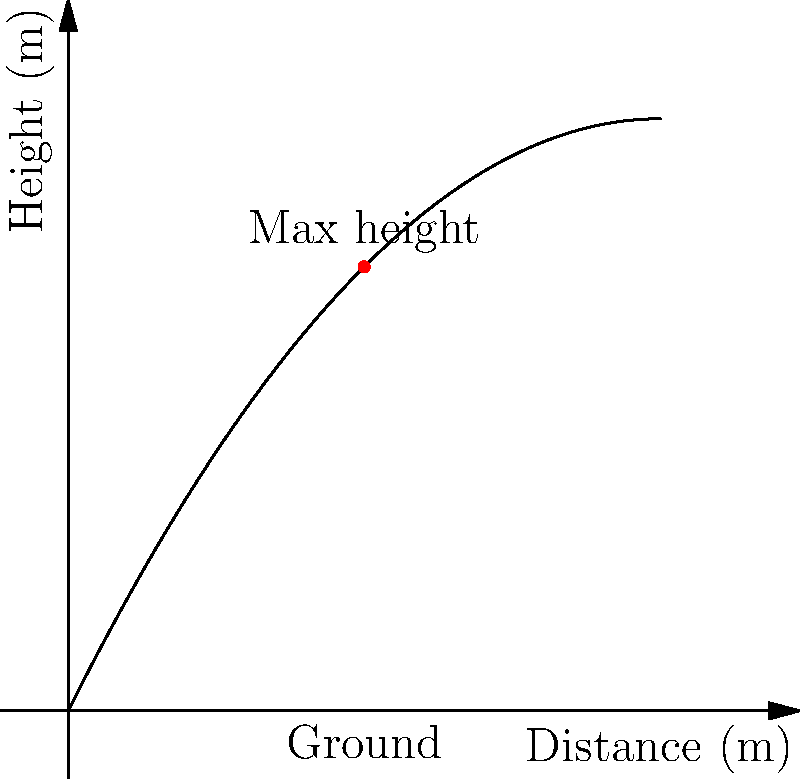In a crucial match against Australia, Indian cricketer Virat Kohli hits a powerful shot. The trajectory of the cricket ball can be modeled by the function $h(x) = -0.05x^2 + 2x$, where $h$ is the height in meters and $x$ is the horizontal distance in meters. At what horizontal distance does the ball reach its maximum height? Use derivatives to solve this problem. To find the maximum height of the ball's trajectory, we need to follow these steps:

1) The maximum height occurs where the derivative of the function is zero. So, we need to find $h'(x)$ and set it equal to zero.

2) Calculate $h'(x)$:
   $h'(x) = \frac{d}{dx}(-0.05x^2 + 2x)$
   $h'(x) = -0.1x + 2$

3) Set $h'(x) = 0$ and solve for $x$:
   $-0.1x + 2 = 0$
   $-0.1x = -2$
   $x = 20$

4) To confirm this is a maximum (not a minimum), we can check the second derivative:
   $h''(x) = -0.1$, which is negative, confirming a maximum.

5) Therefore, the ball reaches its maximum height when $x = 20$ meters.

This result shows that Kohli's powerful hit reaches its peak 20 meters from the point of contact, demonstrating the impressive force behind his shot against the Australian bowlers.
Answer: 20 meters 